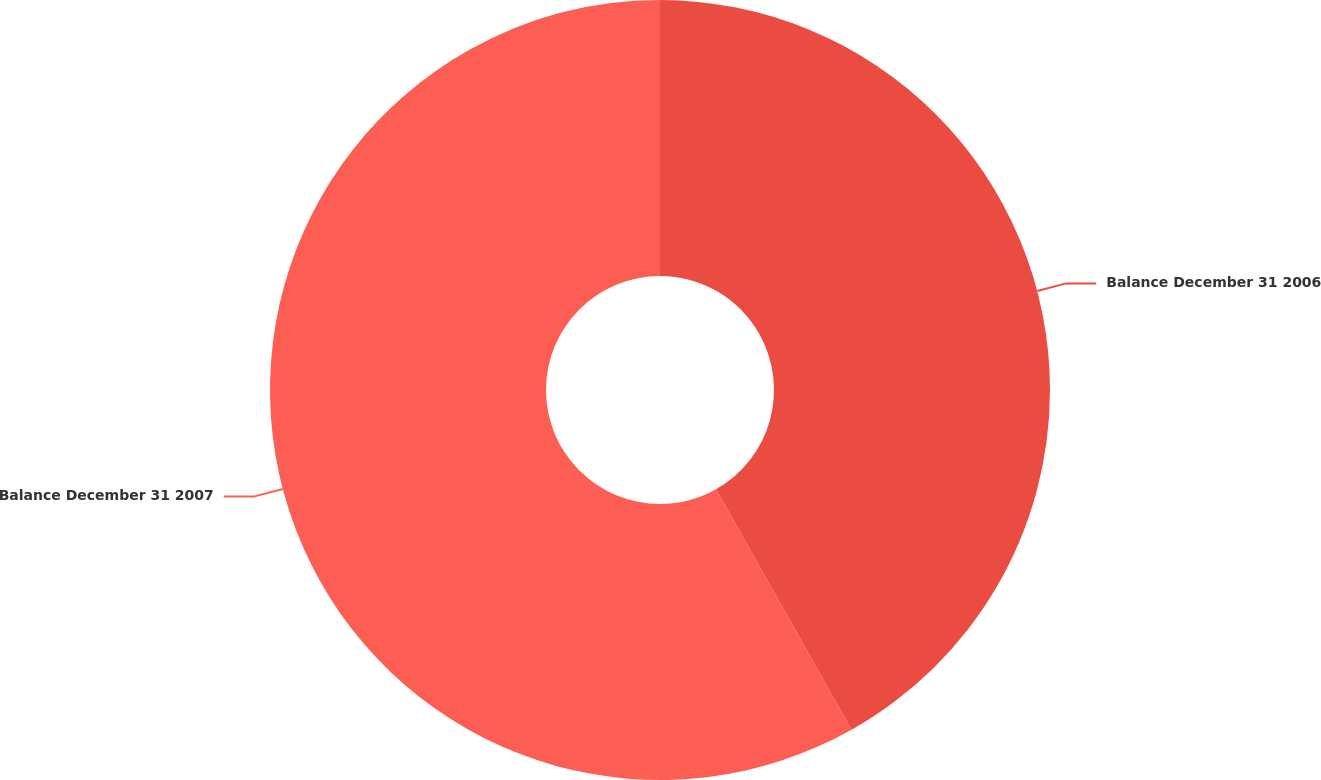Convert chart. <chart><loc_0><loc_0><loc_500><loc_500><pie_chart><fcel>Balance December 31 2006<fcel>Balance December 31 2007<nl><fcel>41.83%<fcel>58.17%<nl></chart> 